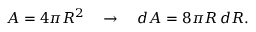Convert formula to latex. <formula><loc_0><loc_0><loc_500><loc_500>A = 4 \pi R ^ { 2 } \quad \rightarrow \quad d A = 8 \pi R \, d R .</formula> 